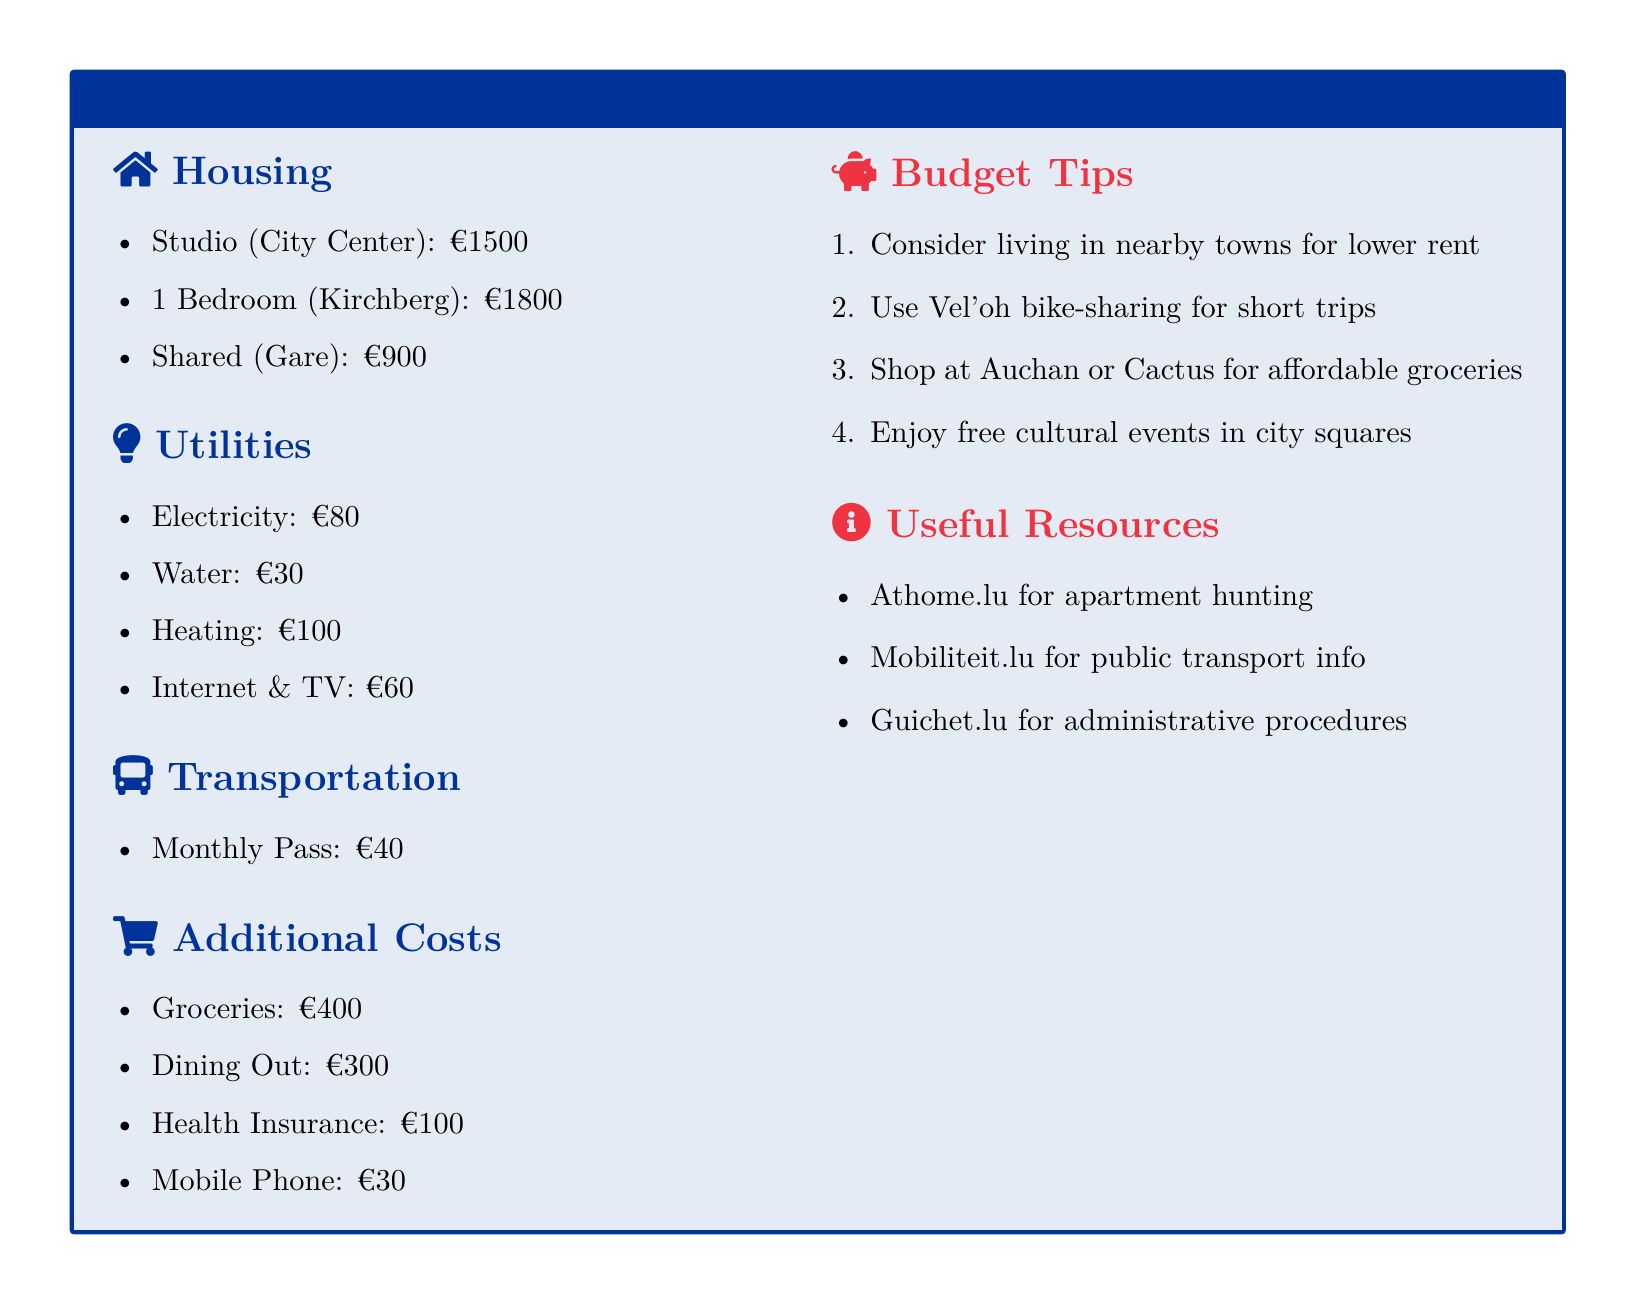What is the rent for a studio in the city center? The rent for a studio in the city center is specified directly in the document.
Answer: €1500 How much do utilities cost in total? The total utilities cost is the sum of all individual utility expenses listed.
Answer: €270 What is the cost of a monthly public transportation pass? The cost for the monthly public transportation pass is stated in the transportation section.
Answer: €40 Which area has the highest rent listed? The document lists different rent prices by area, and the highest is in Kirchberg.
Answer: Kirchberg What is the budget for groceries? The budget for groceries is mentioned in the additional costs section.
Answer: €400 What is one tip for reducing housing costs? The budget tips section offers suggestions for saving, including living in nearby towns.
Answer: Consider living in nearby towns What is the cost of internet and TV? The cost for internet and TV is explicitly provided in the utilities section.
Answer: €60 What is a suggested grocery store for affordable shopping? The document includes names of stores that offer groceries, like Auchan and Cactus.
Answer: Auchan or Cactus How much does health insurance cost? The cost of health insurance is listed under additional costs in the document.
Answer: €100 